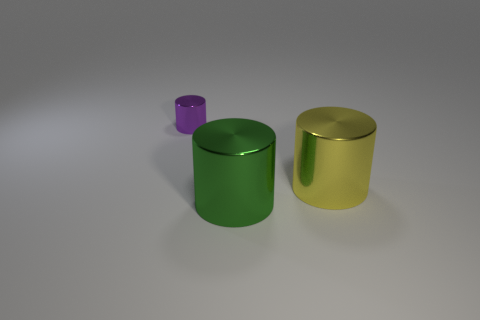Subtract all green metal cylinders. How many cylinders are left? 2 Add 2 large yellow objects. How many objects exist? 5 Subtract all green cylinders. How many cylinders are left? 2 Subtract 1 cylinders. How many cylinders are left? 2 Subtract all brown cylinders. Subtract all cyan cubes. How many cylinders are left? 3 Subtract all big metallic cylinders. Subtract all small blue metallic cylinders. How many objects are left? 1 Add 3 large green cylinders. How many large green cylinders are left? 4 Add 3 tiny cylinders. How many tiny cylinders exist? 4 Subtract 1 purple cylinders. How many objects are left? 2 